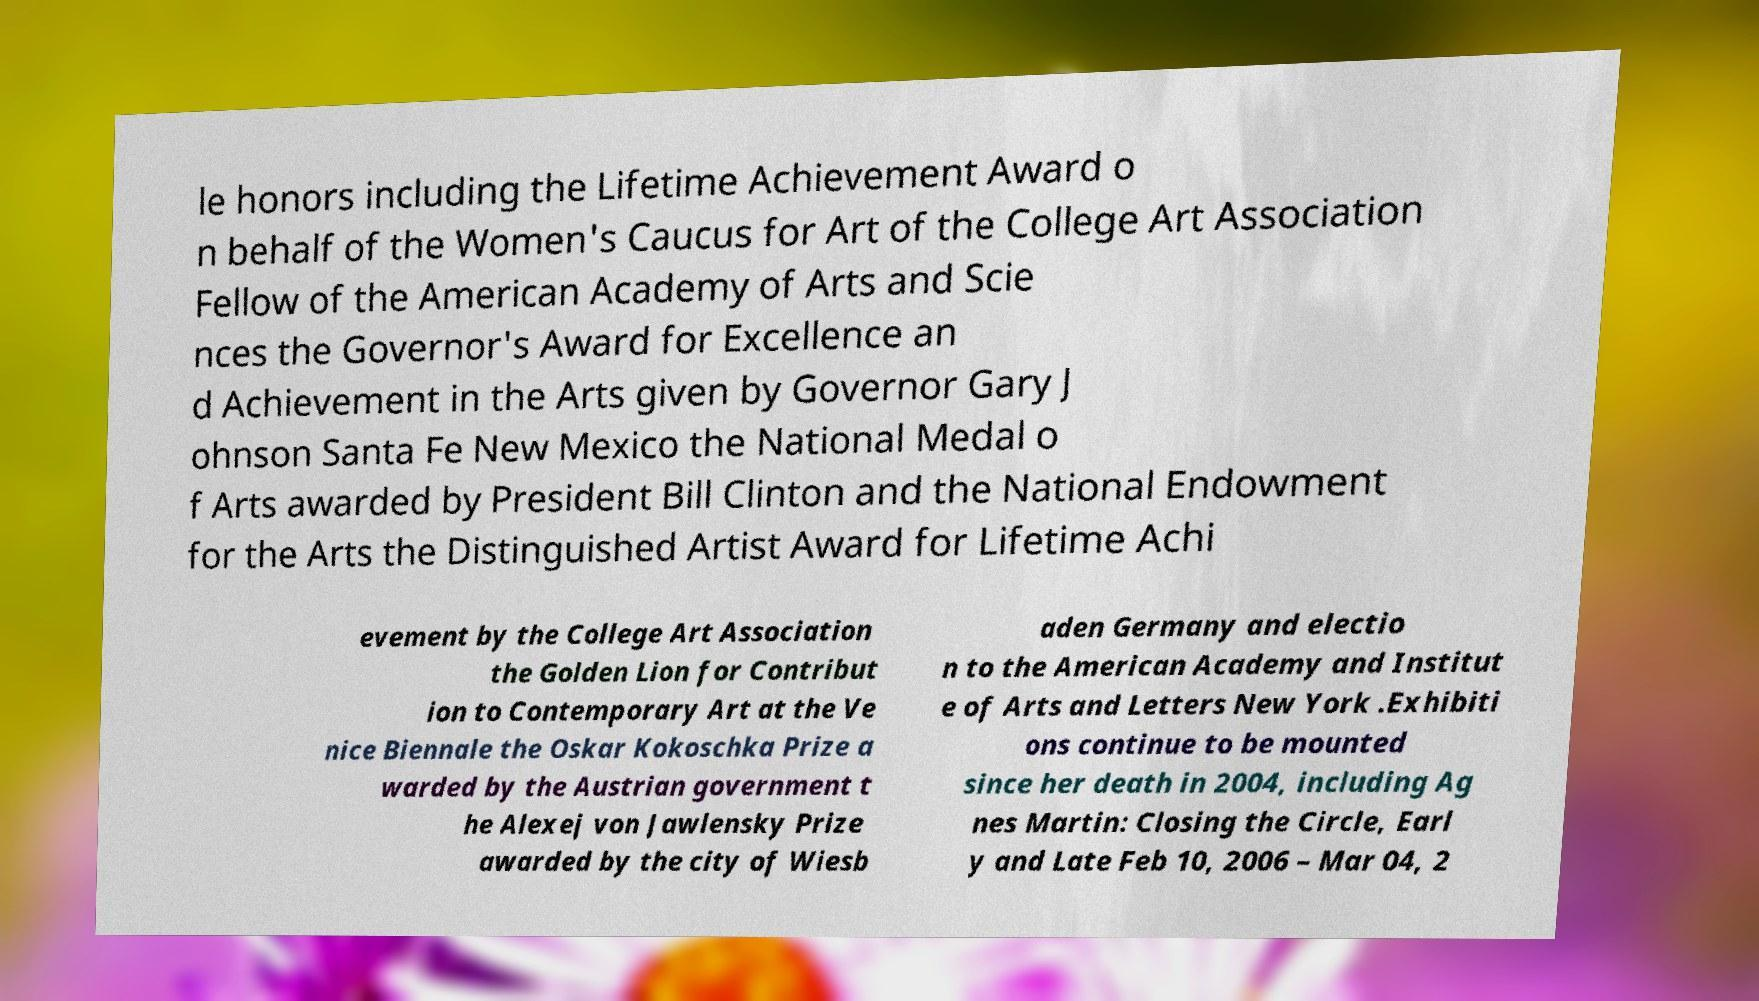Can you accurately transcribe the text from the provided image for me? le honors including the Lifetime Achievement Award o n behalf of the Women's Caucus for Art of the College Art Association Fellow of the American Academy of Arts and Scie nces the Governor's Award for Excellence an d Achievement in the Arts given by Governor Gary J ohnson Santa Fe New Mexico the National Medal o f Arts awarded by President Bill Clinton and the National Endowment for the Arts the Distinguished Artist Award for Lifetime Achi evement by the College Art Association the Golden Lion for Contribut ion to Contemporary Art at the Ve nice Biennale the Oskar Kokoschka Prize a warded by the Austrian government t he Alexej von Jawlensky Prize awarded by the city of Wiesb aden Germany and electio n to the American Academy and Institut e of Arts and Letters New York .Exhibiti ons continue to be mounted since her death in 2004, including Ag nes Martin: Closing the Circle, Earl y and Late Feb 10, 2006 – Mar 04, 2 